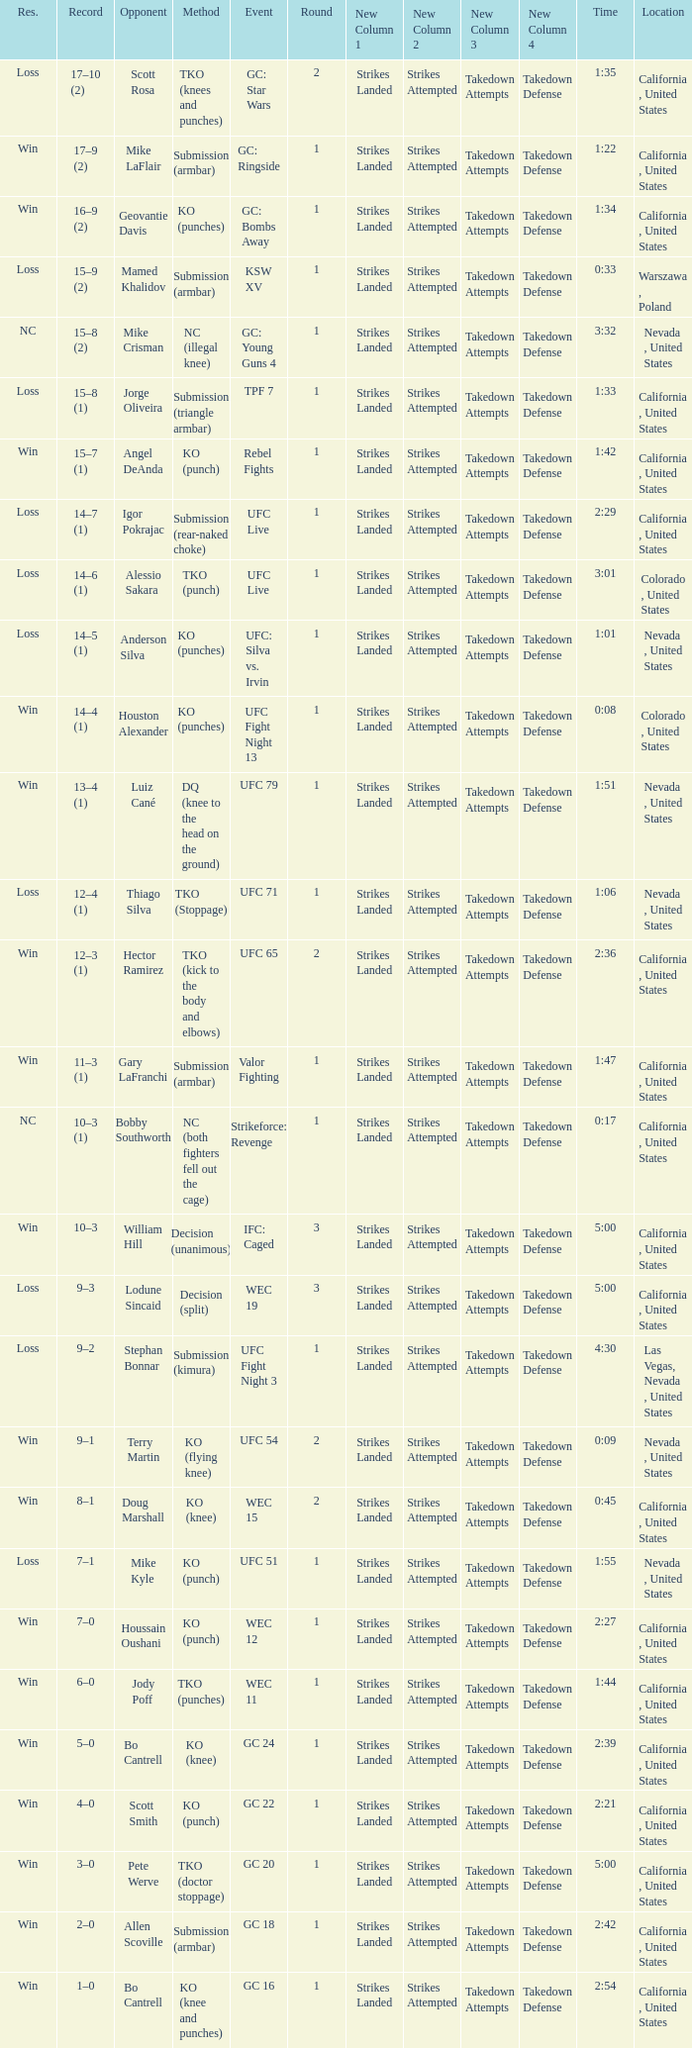What is the method where there is a loss with time 5:00? Decision (split). 